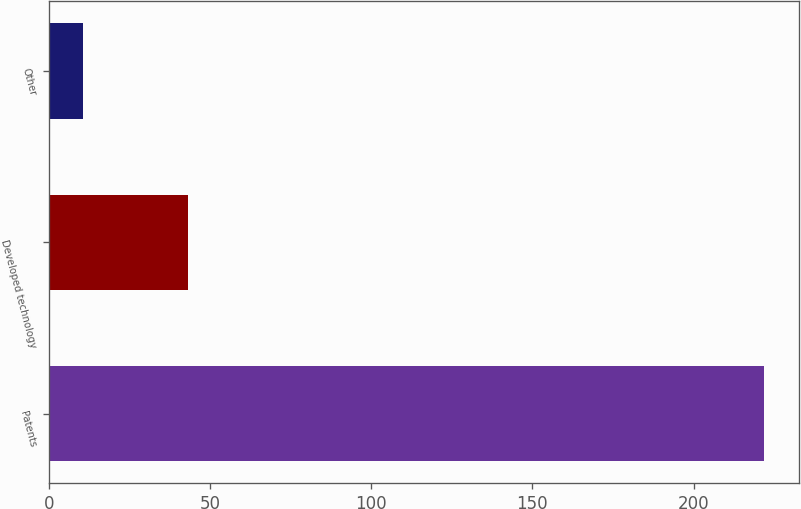Convert chart. <chart><loc_0><loc_0><loc_500><loc_500><bar_chart><fcel>Patents<fcel>Developed technology<fcel>Other<nl><fcel>221.7<fcel>43.3<fcel>10.7<nl></chart> 